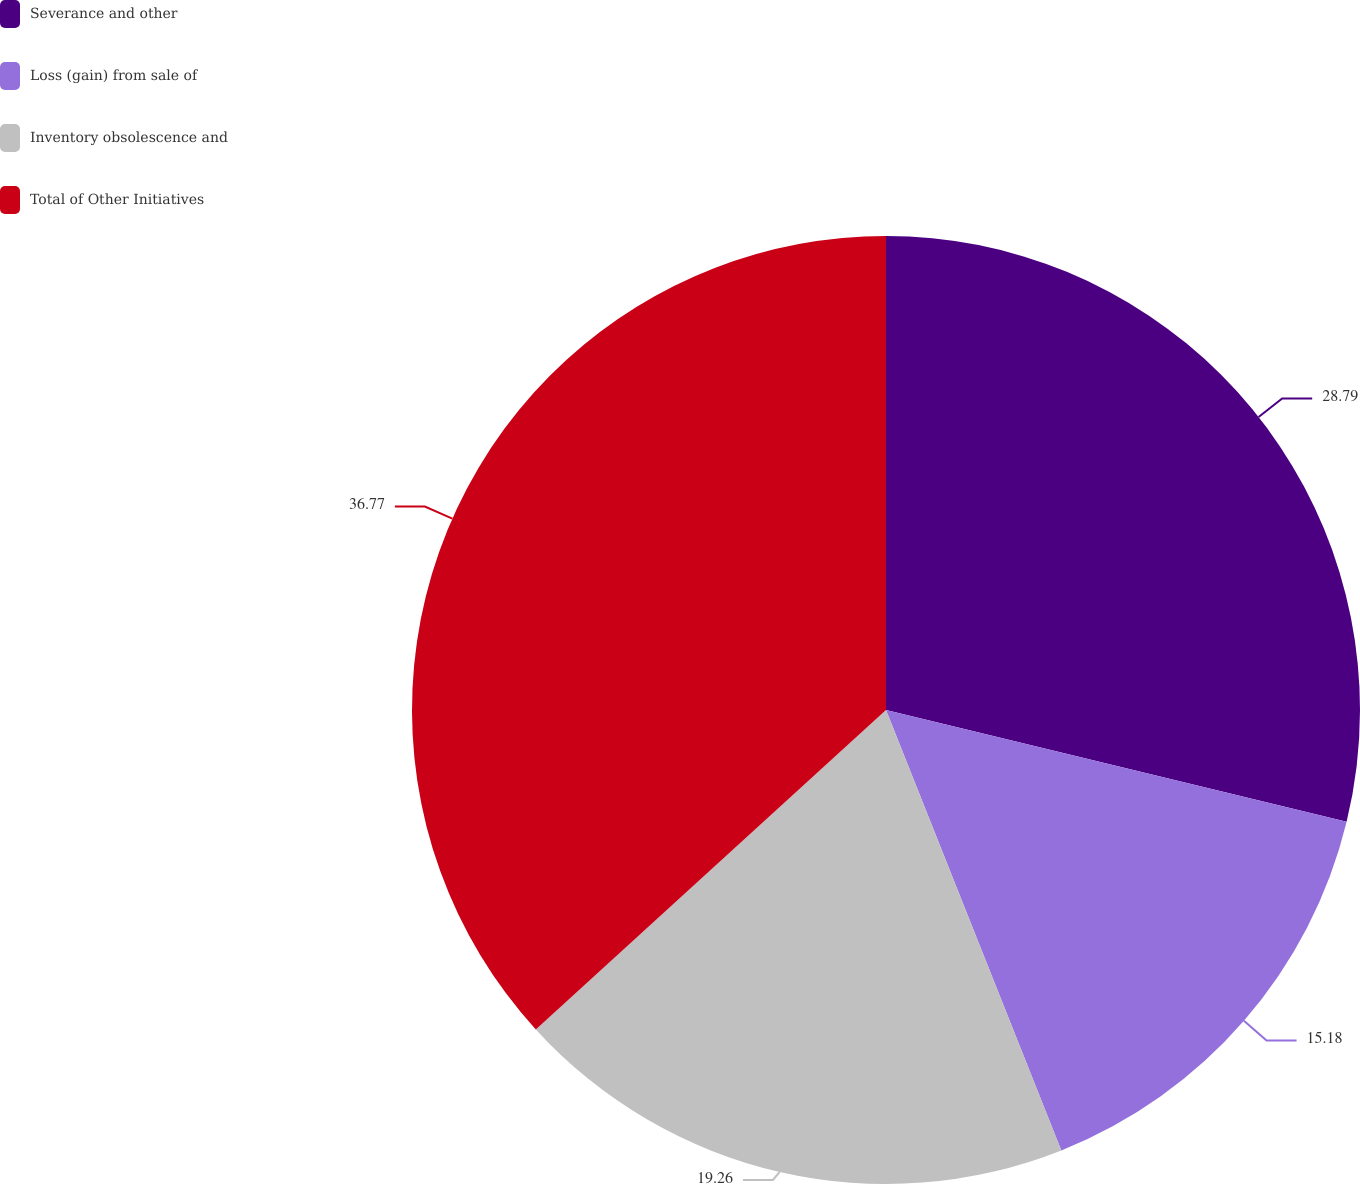Convert chart. <chart><loc_0><loc_0><loc_500><loc_500><pie_chart><fcel>Severance and other<fcel>Loss (gain) from sale of<fcel>Inventory obsolescence and<fcel>Total of Other Initiatives<nl><fcel>28.79%<fcel>15.18%<fcel>19.26%<fcel>36.77%<nl></chart> 